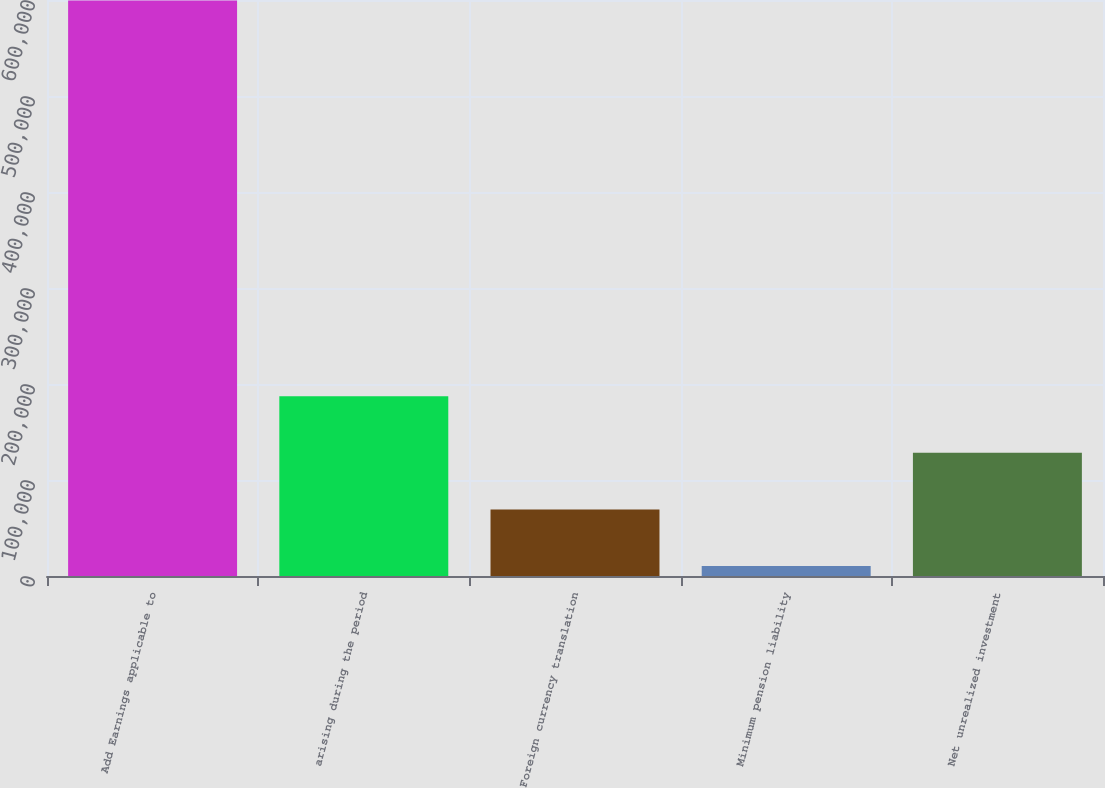<chart> <loc_0><loc_0><loc_500><loc_500><bar_chart><fcel>Add Earnings applicable to<fcel>arising during the period<fcel>Foreign currency translation<fcel>Minimum pension liability<fcel>Net unrealized investment<nl><fcel>599360<fcel>187150<fcel>69376.1<fcel>10489<fcel>128263<nl></chart> 